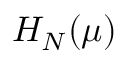Convert formula to latex. <formula><loc_0><loc_0><loc_500><loc_500>H _ { N } ( \mu )</formula> 